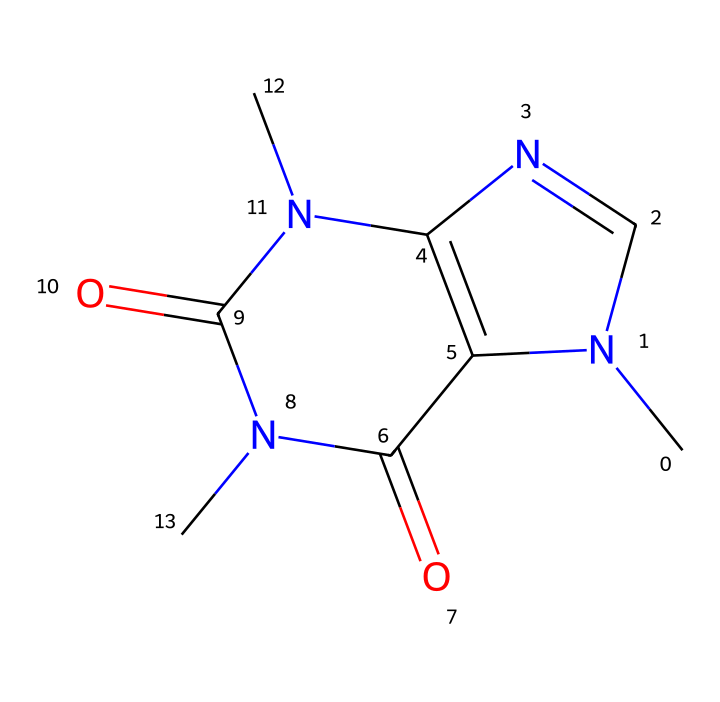What is the molecular formula for this structure? To determine the molecular formula, count the number of each type of atom present in the SMILES representation. The structure includes 8 carbon atoms (C), 10 hydrogen atoms (H), 4 nitrogen atoms (N), and 2 oxygen atoms (O). Therefore, the molecular formula is C8H10N4O2.
Answer: C8H10N4O2 How many rings are present in the structure? Analyzing the SMILES representation reveals that there are two interconnected cyclic structures, indicating that there are 2 rings in total.
Answer: 2 What is the significance of the nitrogen atoms in this antioxidant? The presence of nitrogen atoms, particularly in the context of antioxidants, indicates a potential for reactive sites that can donate electrons, which is a common mechanism of action for antioxidants in neutralizing free radicals.
Answer: reactive sites What type of bonding is primarily present in this antioxidant? The structure is characterized by covalent bonding between the carbon atoms, nitrogen atoms, and functional groups, as indicated by the shared electrons in the molecular representation.
Answer: covalent bonding Identify the part of the molecule that contributes to its antioxidant properties. The carbonyl groups (C=O) adjacent to the nitrogen atoms contribute to electron donation capability, which is essential for the antioxidant functionality, allowing the compound to stabilize free radicals.
Answer: carbonyl groups What is the functional group present in the structure? The molecule contains amide groups (R-CO-NH2), noted from the presence of carbonyl and nitrogen, common in antioxidants for their ability to stabilize radical species.
Answer: amide groups 